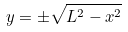Convert formula to latex. <formula><loc_0><loc_0><loc_500><loc_500>y = \pm \sqrt { L ^ { 2 } - x ^ { 2 } }</formula> 